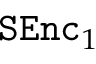<formula> <loc_0><loc_0><loc_500><loc_500>S E n c _ { 1 }</formula> 